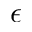<formula> <loc_0><loc_0><loc_500><loc_500>\epsilon</formula> 